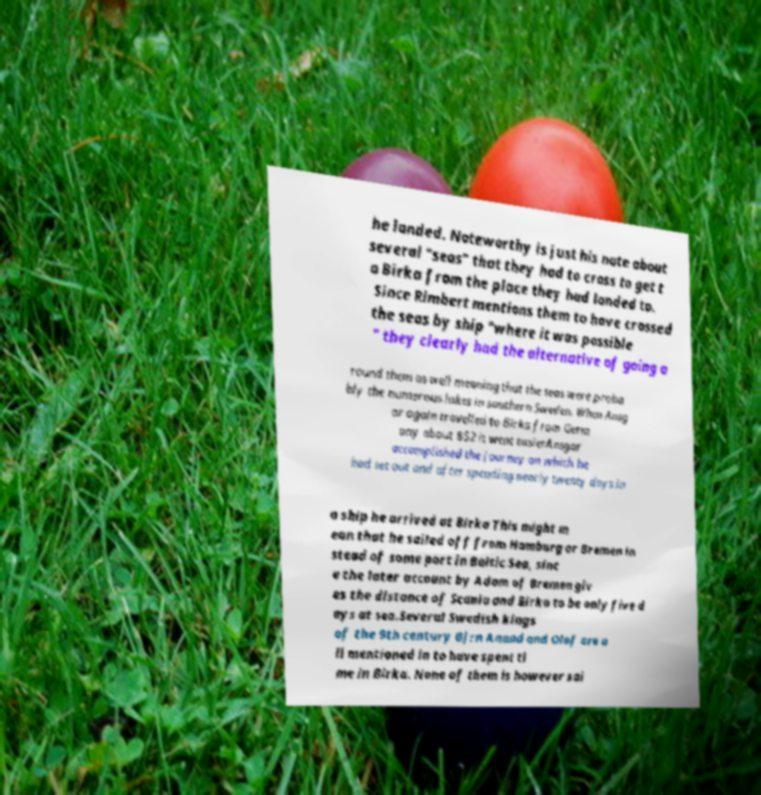Please identify and transcribe the text found in this image. he landed. Noteworthy is just his note about several "seas" that they had to cross to get t o Birka from the place they had landed to. Since Rimbert mentions them to have crossed the seas by ship "where it was possible " they clearly had the alternative of going a round them as well meaning that the seas were proba bly the numerous lakes in southern Sweden. When Ansg ar again travelled to Birka from Germ any about 852 it went easierAnsgar accomplished the journey on which he had set out and after spending nearly twenty days in a ship he arrived at Birka This might m ean that he sailed off from Hamburg or Bremen in stead of some port in Baltic Sea, sinc e the later account by Adam of Bremen giv es the distance of Scania and Birka to be only five d ays at sea.Several Swedish kings of the 9th century Bjrn Anund and Olof are a ll mentioned in to have spent ti me in Birka. None of them is however sai 